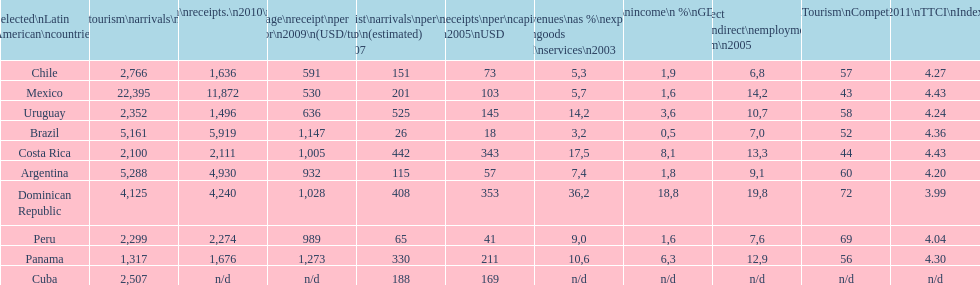During 2003, up to what percentage of gdp did tourism income account for in latin american countries? 18,8. 